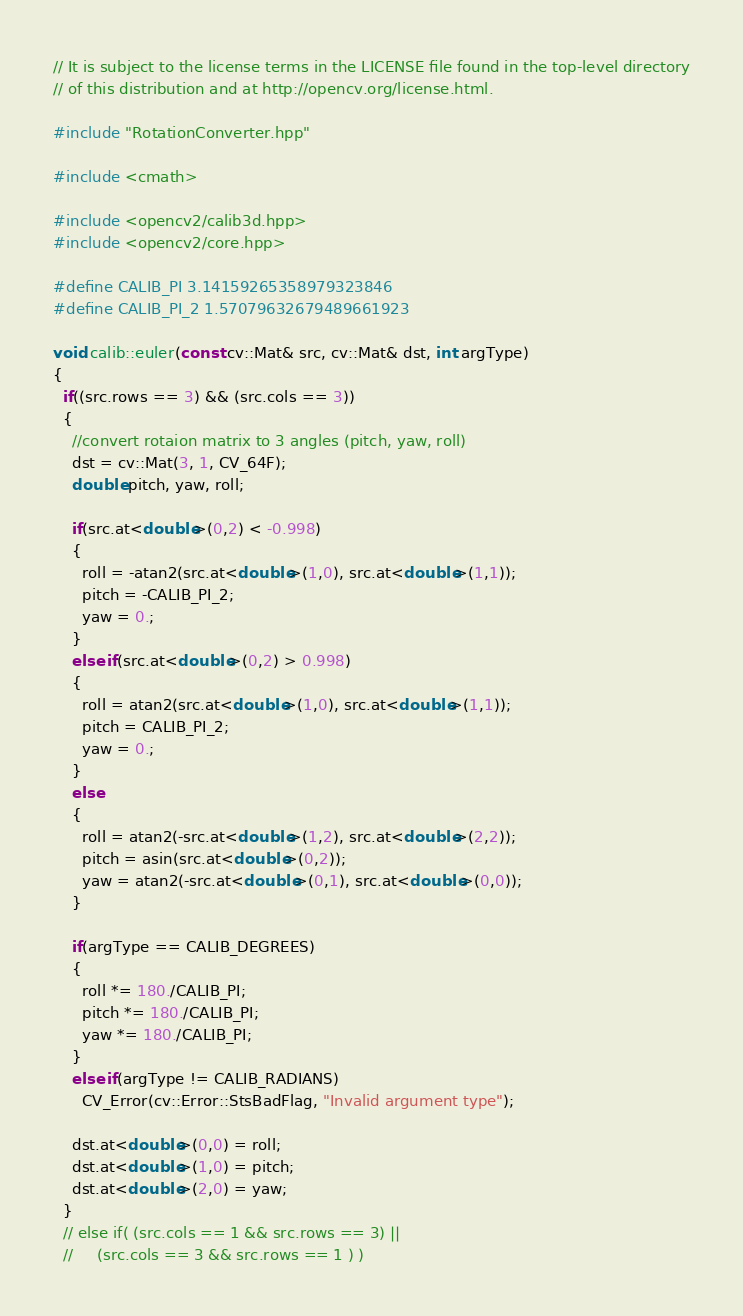<code> <loc_0><loc_0><loc_500><loc_500><_C++_>// It is subject to the license terms in the LICENSE file found in the top-level directory
// of this distribution and at http://opencv.org/license.html.

#include "RotationConverter.hpp"

#include <cmath>

#include <opencv2/calib3d.hpp>
#include <opencv2/core.hpp>

#define CALIB_PI 3.14159265358979323846
#define CALIB_PI_2 1.57079632679489661923

void calib::euler(const cv::Mat& src, cv::Mat& dst, int argType)
{
  if((src.rows == 3) && (src.cols == 3))
  {
    //convert rotaion matrix to 3 angles (pitch, yaw, roll)
    dst = cv::Mat(3, 1, CV_64F);
    double pitch, yaw, roll;

    if(src.at<double>(0,2) < -0.998)
    {
      roll = -atan2(src.at<double>(1,0), src.at<double>(1,1));
      pitch = -CALIB_PI_2;
      yaw = 0.;
    }
    else if(src.at<double>(0,2) > 0.998)
    {
      roll = atan2(src.at<double>(1,0), src.at<double>(1,1));
      pitch = CALIB_PI_2;
      yaw = 0.;
    }
    else
    {
      roll = atan2(-src.at<double>(1,2), src.at<double>(2,2));
      pitch = asin(src.at<double>(0,2));
      yaw = atan2(-src.at<double>(0,1), src.at<double>(0,0));
    }

    if(argType == CALIB_DEGREES)
    {
      roll *= 180./CALIB_PI;
      pitch *= 180./CALIB_PI;
      yaw *= 180./CALIB_PI;
    }
    else if(argType != CALIB_RADIANS)
      CV_Error(cv::Error::StsBadFlag, "Invalid argument type");

    dst.at<double>(0,0) = roll;
    dst.at<double>(1,0) = pitch;
    dst.at<double>(2,0) = yaw;
  }
  // else if( (src.cols == 1 && src.rows == 3) ||
  //     (src.cols == 3 && src.rows == 1 ) )</code> 